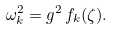<formula> <loc_0><loc_0><loc_500><loc_500>\omega _ { k } ^ { 2 } = g ^ { 2 } \, f _ { k } ( \zeta ) .</formula> 